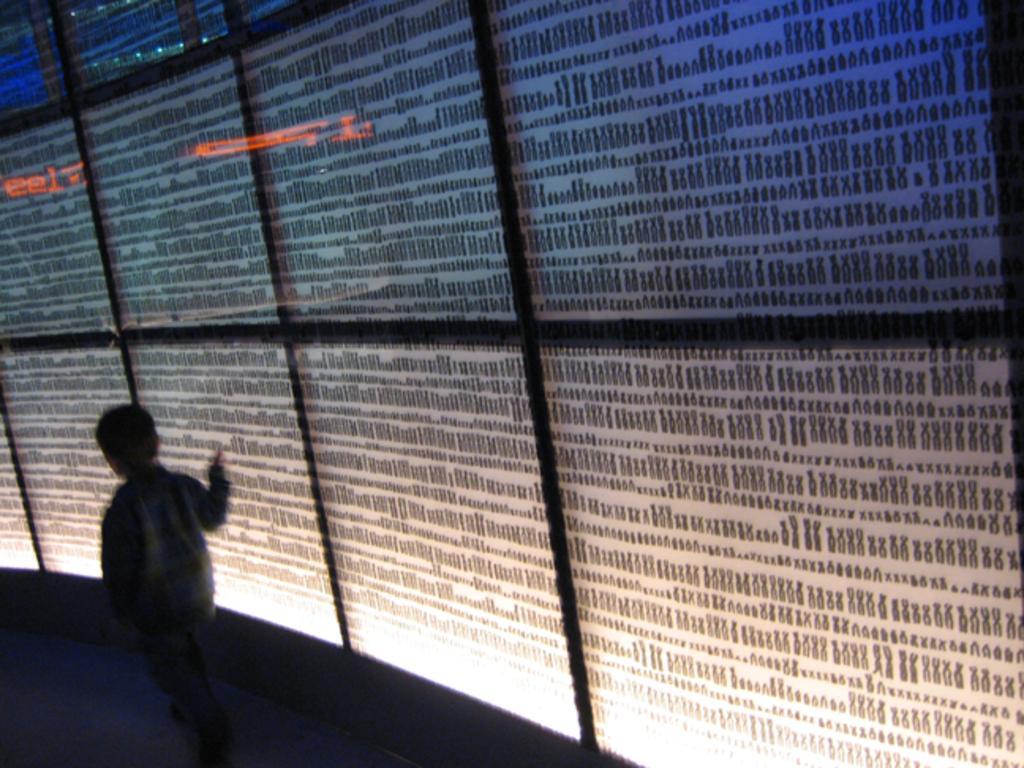In one or two sentences, can you explain what this image depicts? On the left side there is a person is walking. On the right side there is a glass, behind this there is a sheet. 